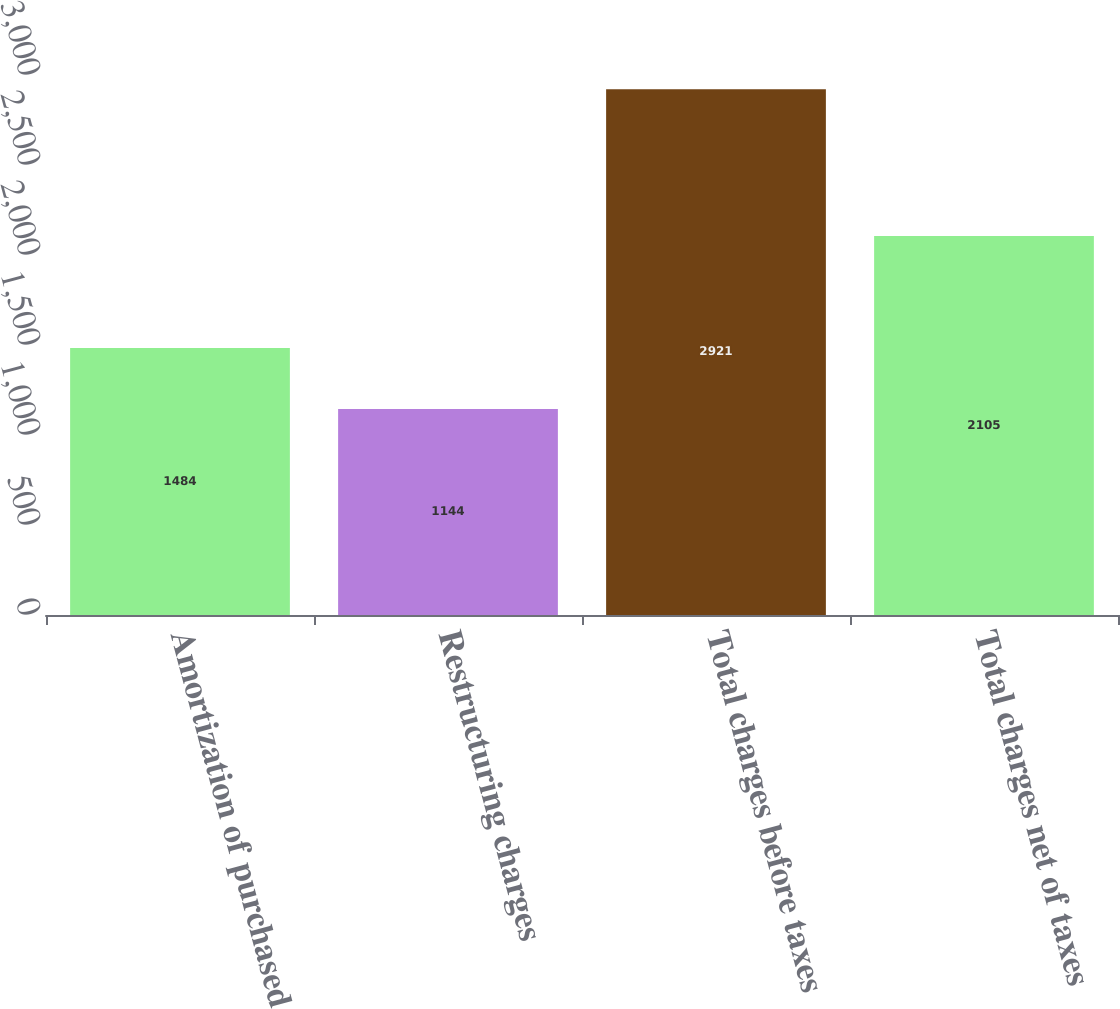Convert chart. <chart><loc_0><loc_0><loc_500><loc_500><bar_chart><fcel>Amortization of purchased<fcel>Restructuring charges<fcel>Total charges before taxes<fcel>Total charges net of taxes<nl><fcel>1484<fcel>1144<fcel>2921<fcel>2105<nl></chart> 